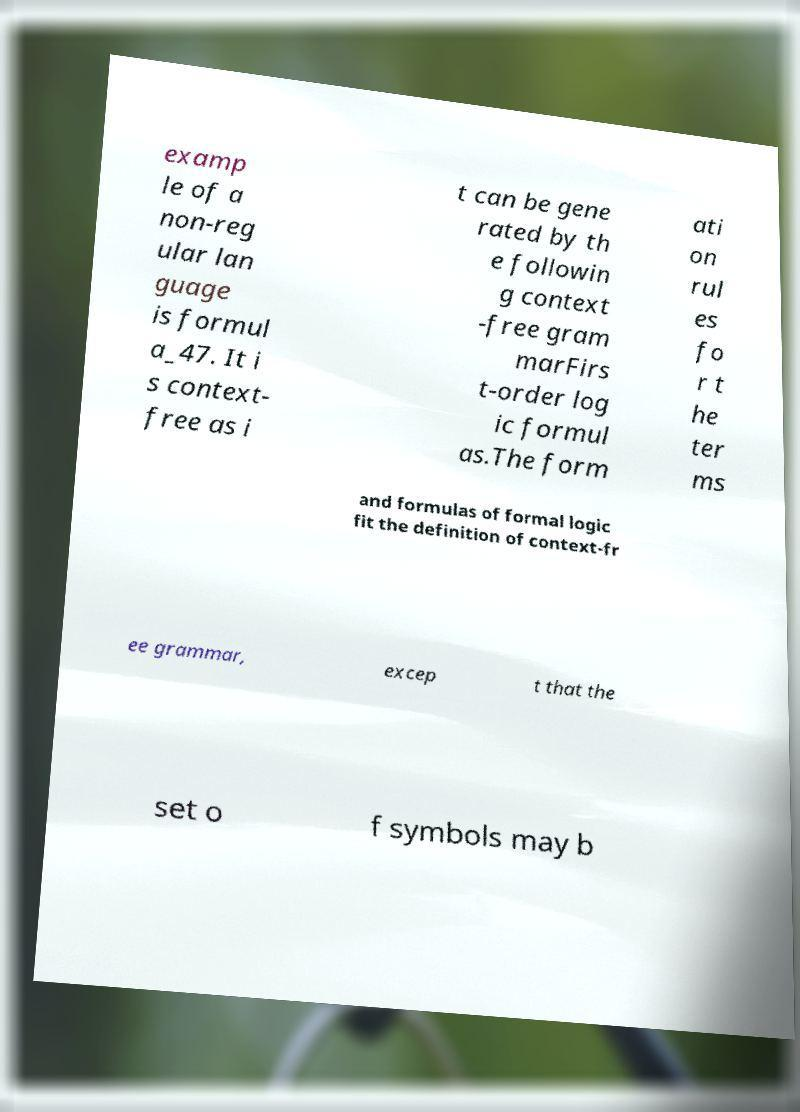Can you accurately transcribe the text from the provided image for me? examp le of a non-reg ular lan guage is formul a_47. It i s context- free as i t can be gene rated by th e followin g context -free gram marFirs t-order log ic formul as.The form ati on rul es fo r t he ter ms and formulas of formal logic fit the definition of context-fr ee grammar, excep t that the set o f symbols may b 